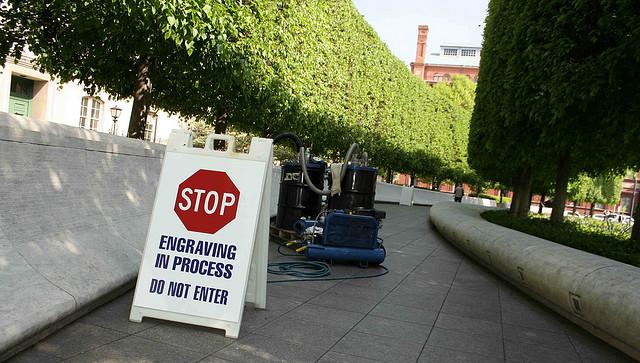What does the white sign say?
Give a very brief answer. Stop engraving in process do not enter. What time of day is this?
Write a very short answer. Daytime. Why can't you enter this street?
Be succinct. Engraving in process. 